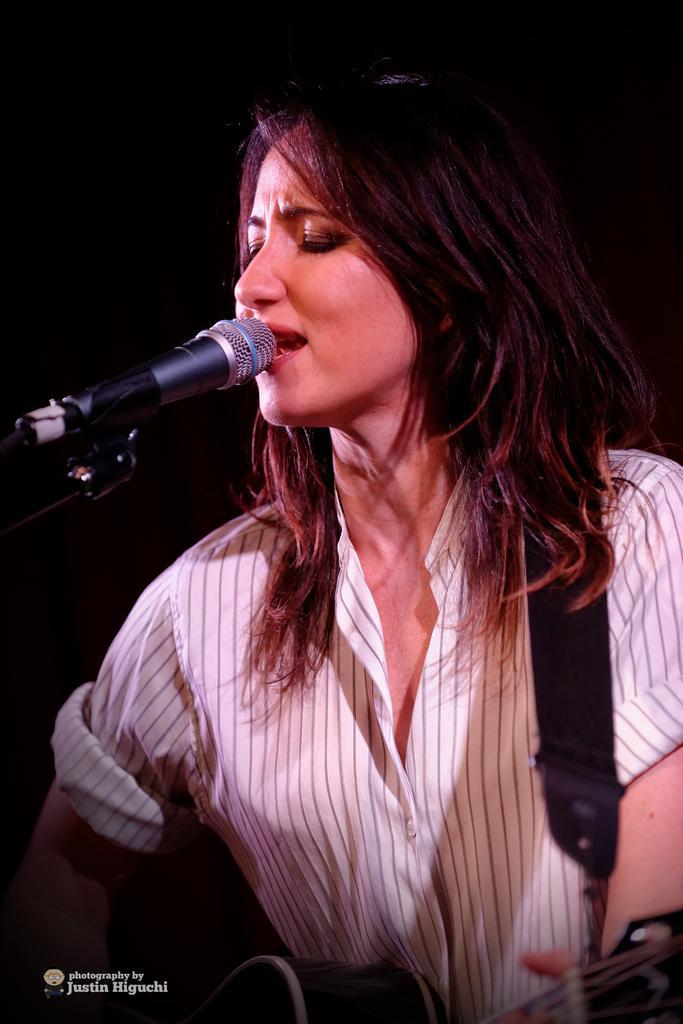How would you summarize this image in a sentence or two? This is the woman holding a guitar and singing. This is a mike. The background looks dark. At the bottom of the image, I can see the watermark. 